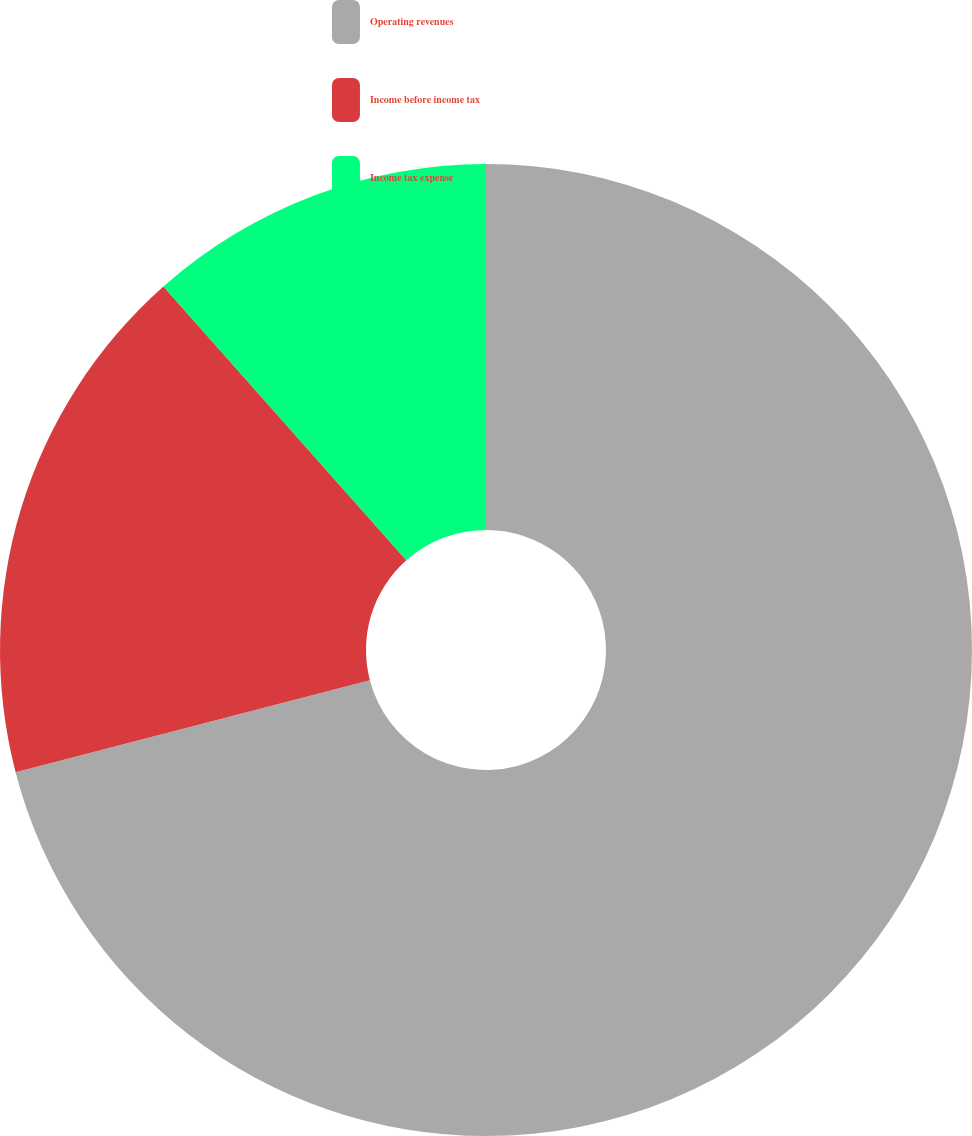Convert chart. <chart><loc_0><loc_0><loc_500><loc_500><pie_chart><fcel>Operating revenues<fcel>Income before income tax<fcel>Income tax expense<nl><fcel>70.95%<fcel>17.49%<fcel>11.55%<nl></chart> 